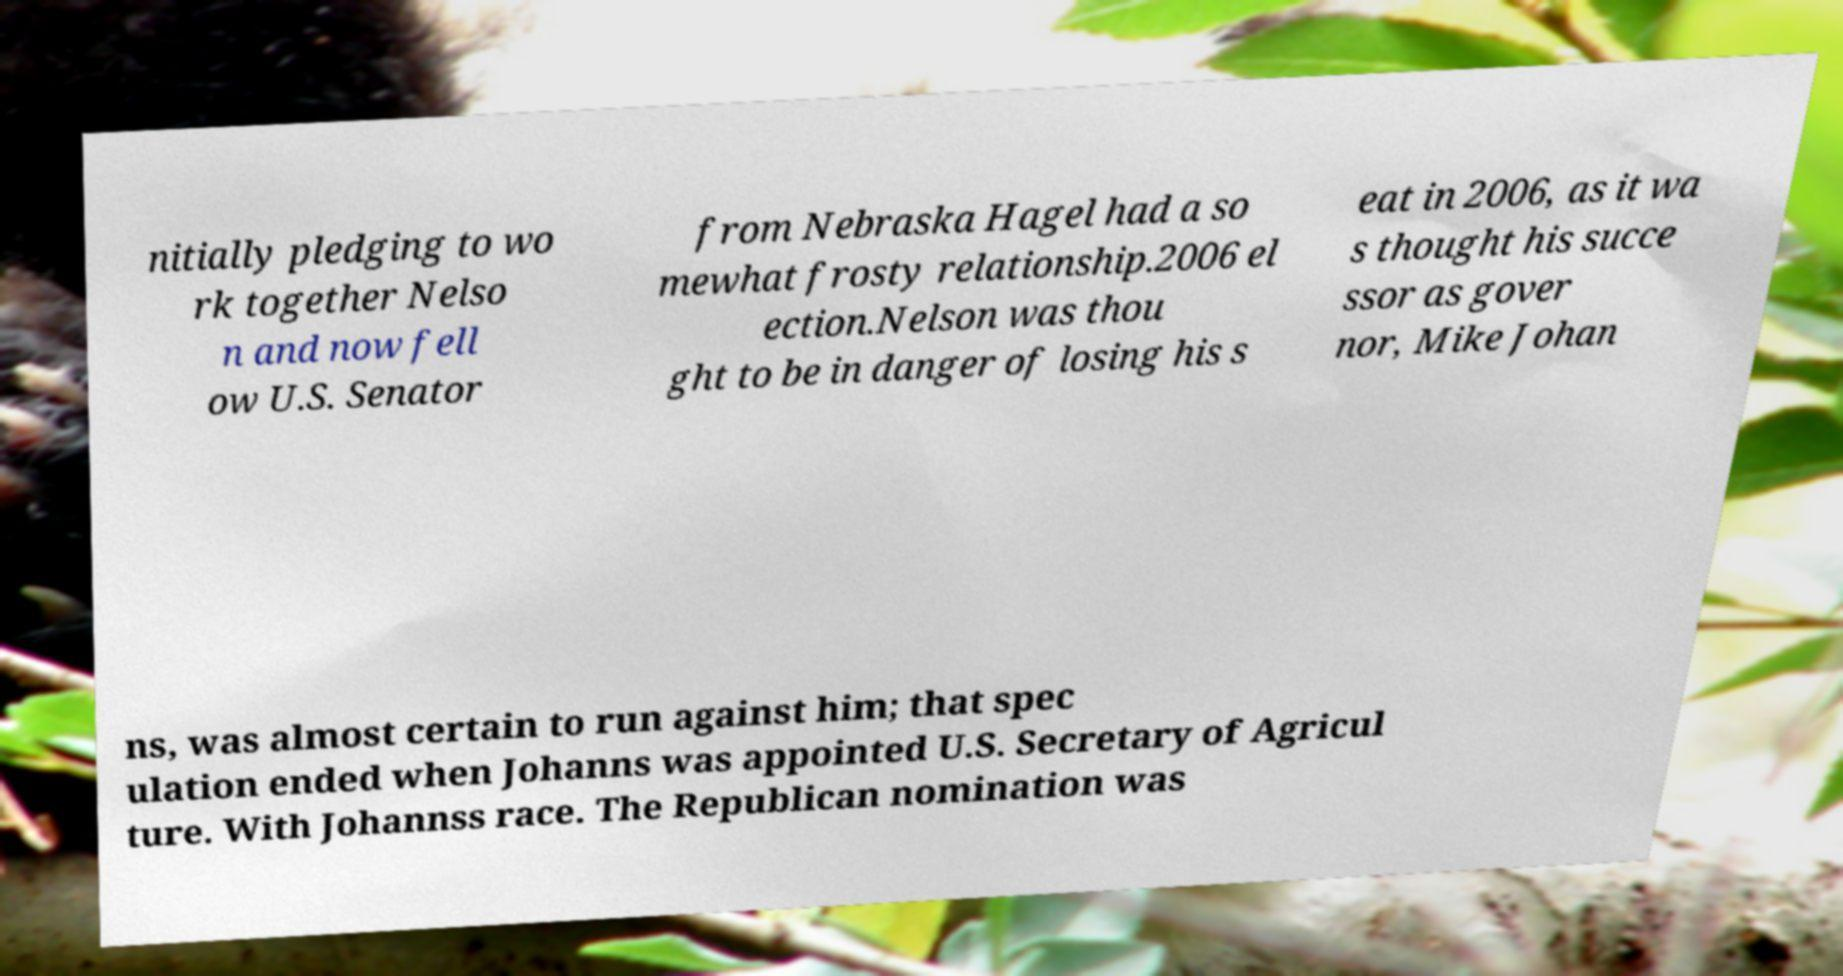Could you extract and type out the text from this image? nitially pledging to wo rk together Nelso n and now fell ow U.S. Senator from Nebraska Hagel had a so mewhat frosty relationship.2006 el ection.Nelson was thou ght to be in danger of losing his s eat in 2006, as it wa s thought his succe ssor as gover nor, Mike Johan ns, was almost certain to run against him; that spec ulation ended when Johanns was appointed U.S. Secretary of Agricul ture. With Johannss race. The Republican nomination was 